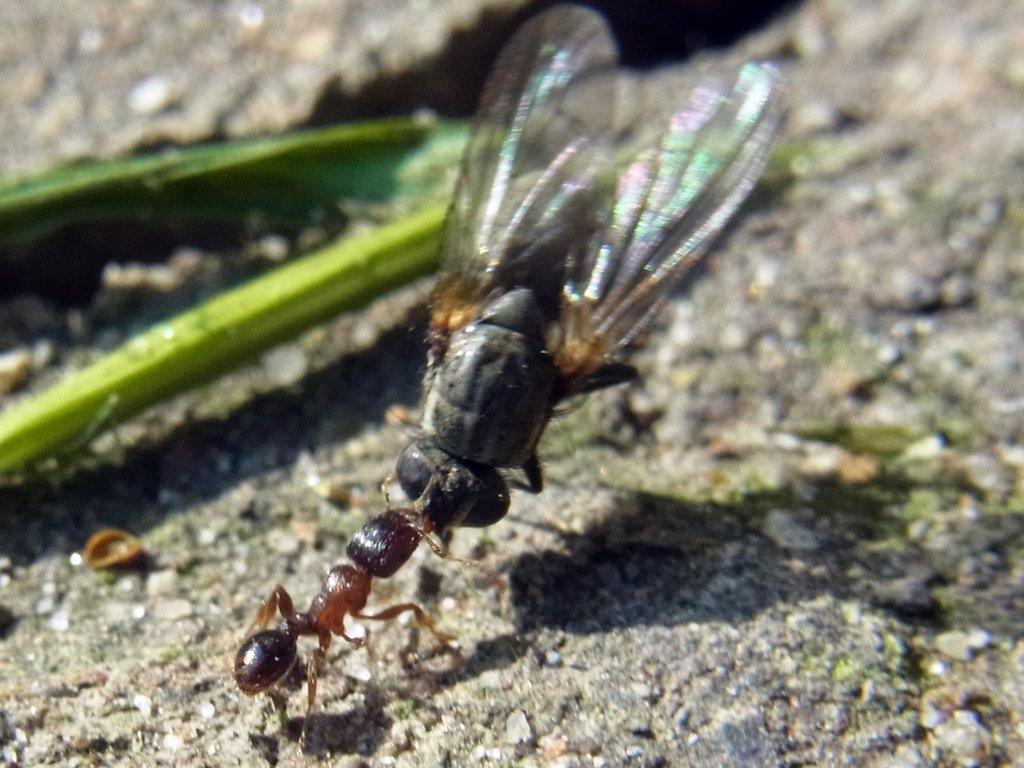What type of insects can be seen in the image? There is an ant and a house fly in the image. What color is the item visible in the image? There is a green color item in the image. Where are these objects located in the image? All of these objects are on the ground. What type of patch is being used to mend the crook in the image? There is no patch or crook present in the image; it only features an ant, a house fly, and a green item on the ground. 